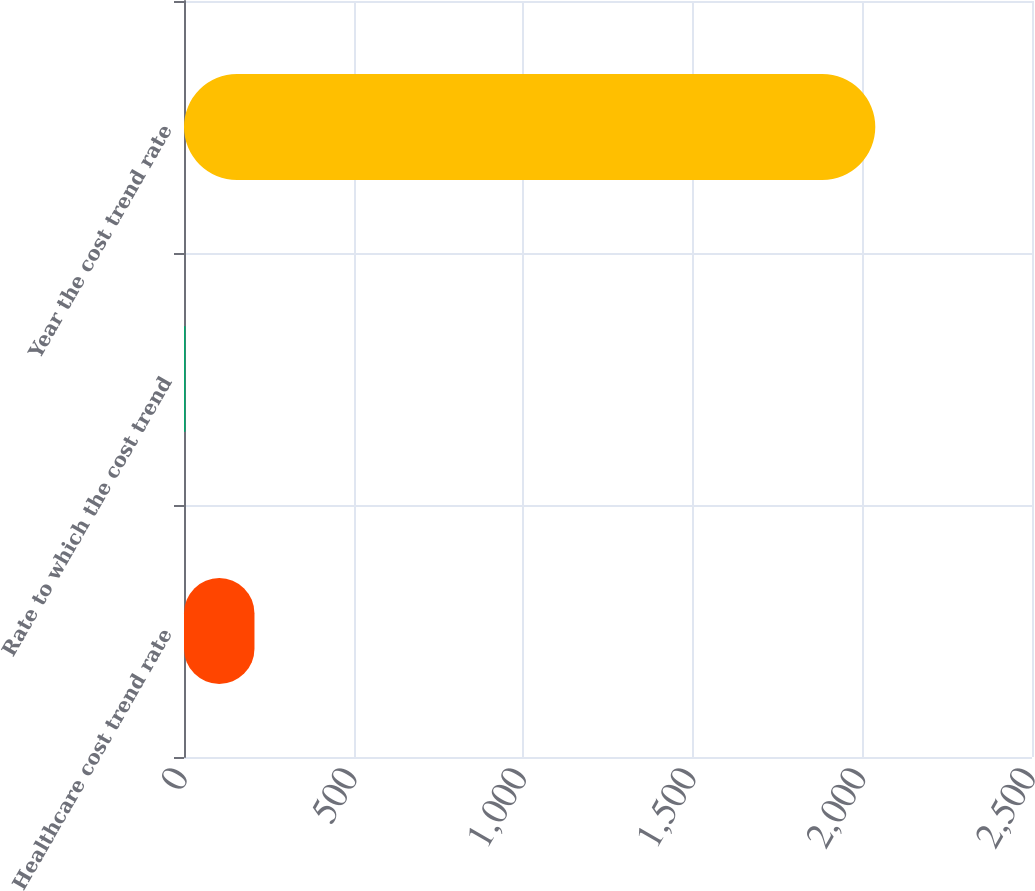<chart> <loc_0><loc_0><loc_500><loc_500><bar_chart><fcel>Healthcare cost trend rate<fcel>Rate to which the cost trend<fcel>Year the cost trend rate<nl><fcel>207.76<fcel>4.4<fcel>2038<nl></chart> 